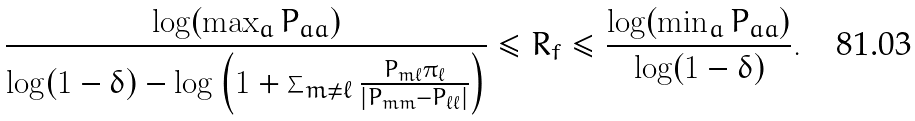Convert formula to latex. <formula><loc_0><loc_0><loc_500><loc_500>\frac { \log ( \max _ { a } P _ { a a } ) } { \log ( 1 - \delta ) - \log \left ( 1 + \sum _ { m \neq \ell } \frac { P _ { m \ell } \pi _ { \ell } } { | P _ { m m } - P _ { \ell \ell } | } \right ) } \leq R _ { f } \leq \frac { \log ( \min _ { a } P _ { a a } ) } { \log ( 1 - \delta ) } .</formula> 